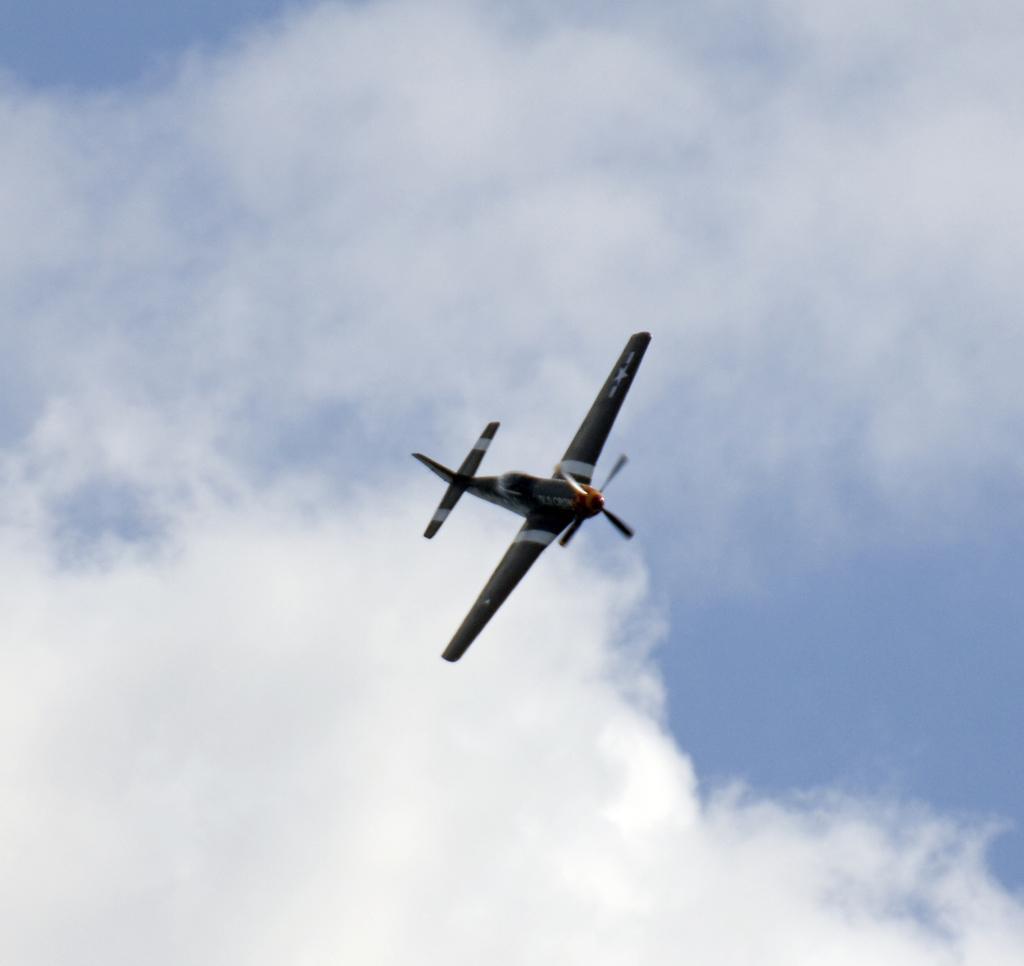In one or two sentences, can you explain what this image depicts? In the image I can see a helicopter which is flying in the air and also I can see the cloudy sky. 